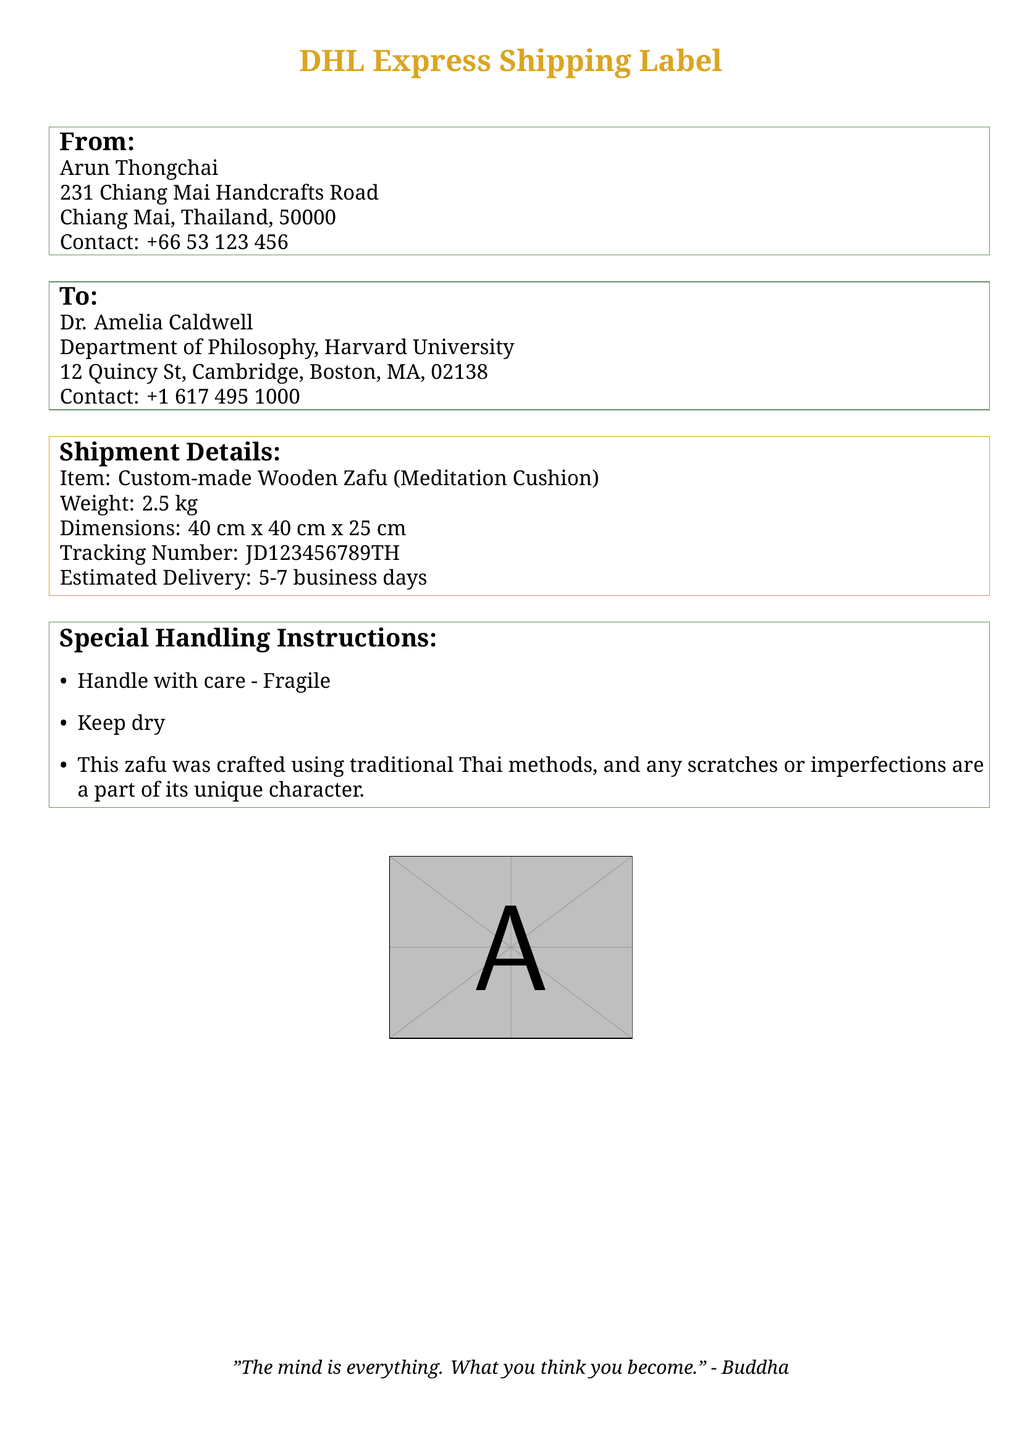What is the sender's name? The sender's name is listed in the "From" section of the document as Arun Thongchai.
Answer: Arun Thongchai What is the recipient's contact number? The recipient's contact number is found in the "To" section of the document as +1 617 495 1000.
Answer: +1 617 495 1000 What is the weight of the zafu? The weight is provided in the "Shipment Details" section of the document as 2.5 kg.
Answer: 2.5 kg What are the dimensions of the zafu? The dimensions are specified in the "Shipment Details" section: 40 cm x 40 cm x 25 cm.
Answer: 40 cm x 40 cm x 25 cm What is the estimated delivery time? The estimated delivery time is stated in the "Shipment Details" section as 5-7 business days.
Answer: 5-7 business days What special instructions are provided regarding the zafu? The special handling instructions in the document advise to handle with care and keep dry.
Answer: Handle with care - Fragile, Keep dry Why might there be imperfections on the zafu? The document notes that imperfections are a part of its unique character due to traditional Thai crafting methods.
Answer: Traditional Thai methods What type of item is being shipped? The document identifies the item in the "Shipment Details" as a Custom-made Wooden Zafu.
Answer: Custom-made Wooden Zafu What is the tracking number of this shipment? The tracking number is clearly indicated in the "Shipment Details" section of the document as JD123456789TH.
Answer: JD123456789TH 